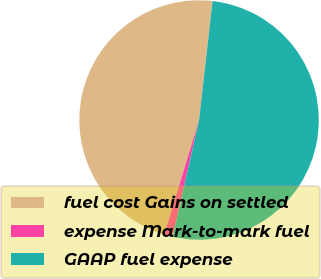<chart> <loc_0><loc_0><loc_500><loc_500><pie_chart><fcel>fuel cost Gains on settled<fcel>expense Mark-to-mark fuel<fcel>GAAP fuel expense<nl><fcel>47.09%<fcel>1.16%<fcel>51.74%<nl></chart> 